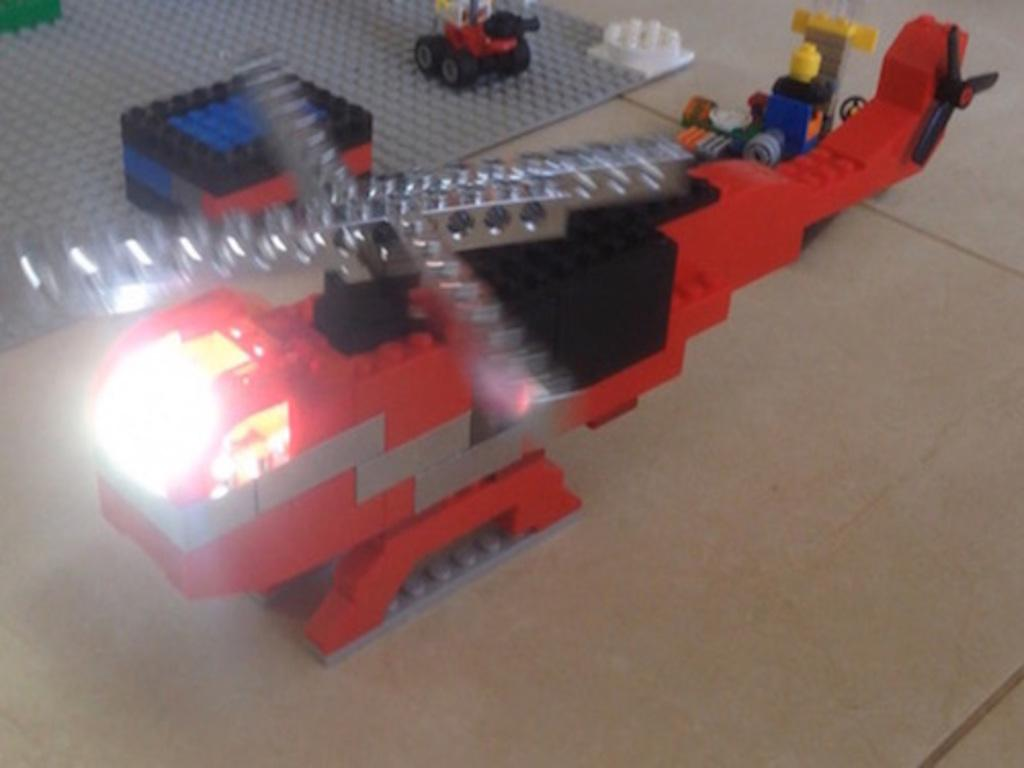What type of toy is present in the image? There are Lego bricks in the image. Where are the Lego bricks located? The Lego bricks are on the floor. What type of cart is used to transport the Lego bricks in the image? There is no cart present in the image; the Lego bricks are on the floor. What invention is being demonstrated in the image? There is no invention being demonstrated in the image; it simply shows Lego bricks on the floor. 